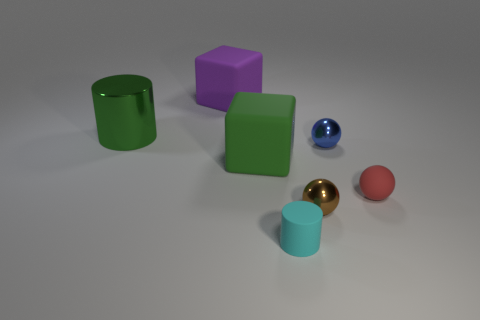What is the shape of the big rubber thing that is in front of the big purple rubber object?
Give a very brief answer. Cube. There is a metal object in front of the tiny red sphere; is it the same color as the rubber ball?
Offer a terse response. No. Is the number of blue shiny spheres that are right of the blue metal object less than the number of tiny blue metallic spheres?
Make the answer very short. Yes. What is the color of the ball that is the same material as the tiny blue thing?
Give a very brief answer. Brown. There is a ball on the right side of the small blue shiny sphere; what is its size?
Make the answer very short. Small. Are the large cylinder and the brown thing made of the same material?
Your answer should be compact. Yes. There is a big green thing on the left side of the cube in front of the purple cube; are there any rubber blocks that are behind it?
Keep it short and to the point. Yes. The tiny rubber cylinder has what color?
Your answer should be compact. Cyan. The other matte object that is the same size as the red rubber object is what color?
Your answer should be very brief. Cyan. Do the large object that is to the left of the large purple thing and the cyan rubber thing have the same shape?
Ensure brevity in your answer.  Yes. 